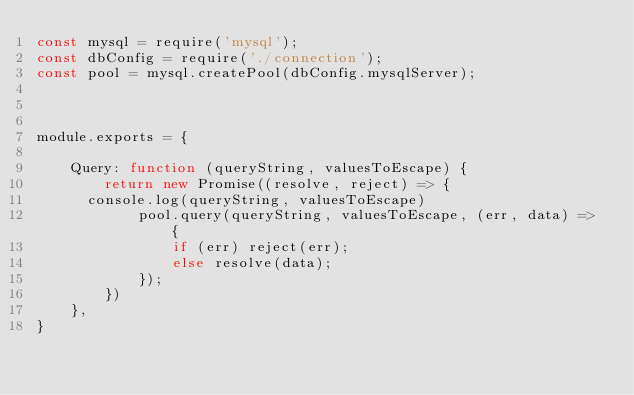<code> <loc_0><loc_0><loc_500><loc_500><_JavaScript_>const mysql = require('mysql');
const dbConfig = require('./connection');
const pool = mysql.createPool(dbConfig.mysqlServer);



module.exports = {

    Query: function (queryString, valuesToEscape) {
        return new Promise((resolve, reject) => {
			console.log(queryString, valuesToEscape)
            pool.query(queryString, valuesToEscape, (err, data) => {
                if (err) reject(err);
                else resolve(data);
            });
        })
    },
}
</code> 